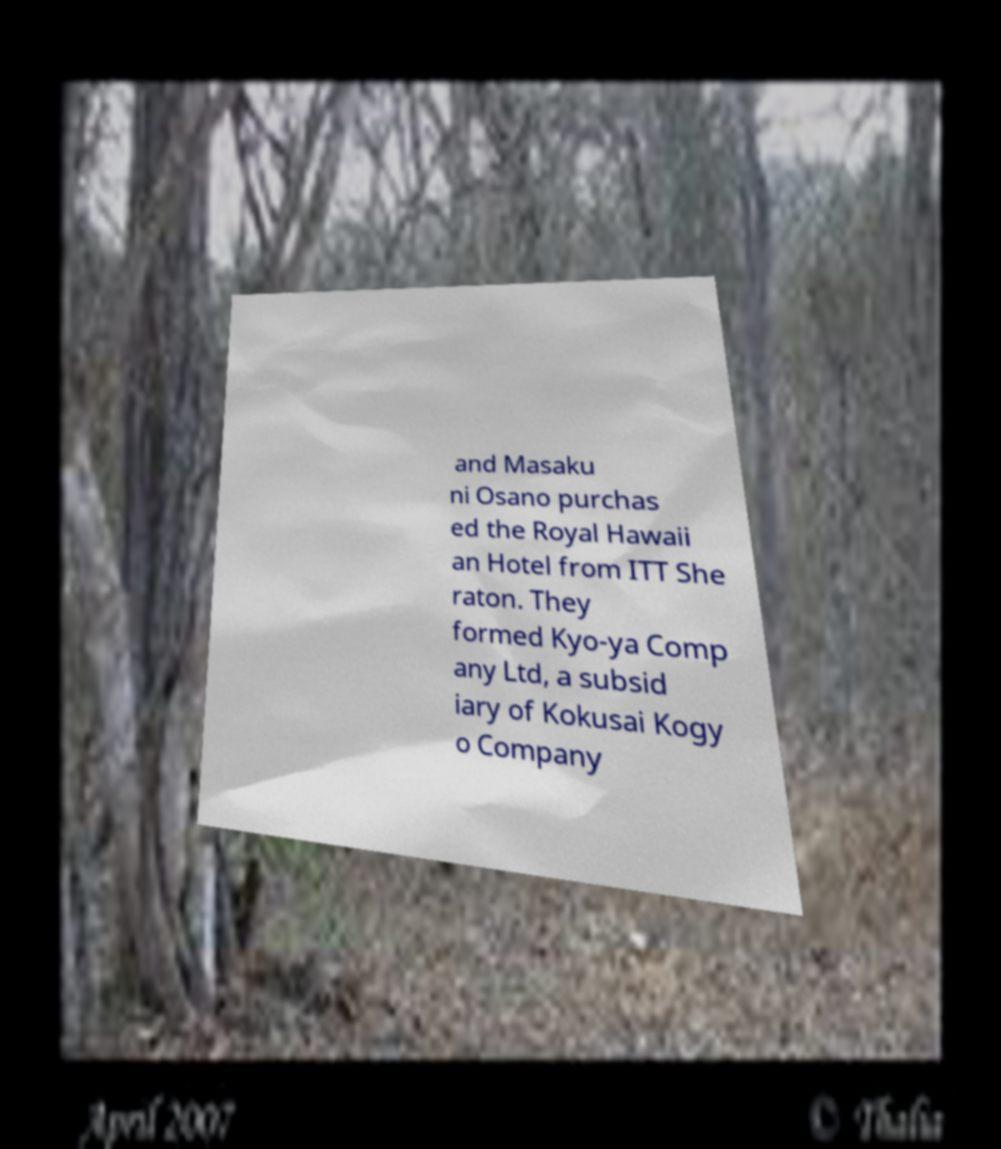Please identify and transcribe the text found in this image. and Masaku ni Osano purchas ed the Royal Hawaii an Hotel from ITT She raton. They formed Kyo-ya Comp any Ltd, a subsid iary of Kokusai Kogy o Company 